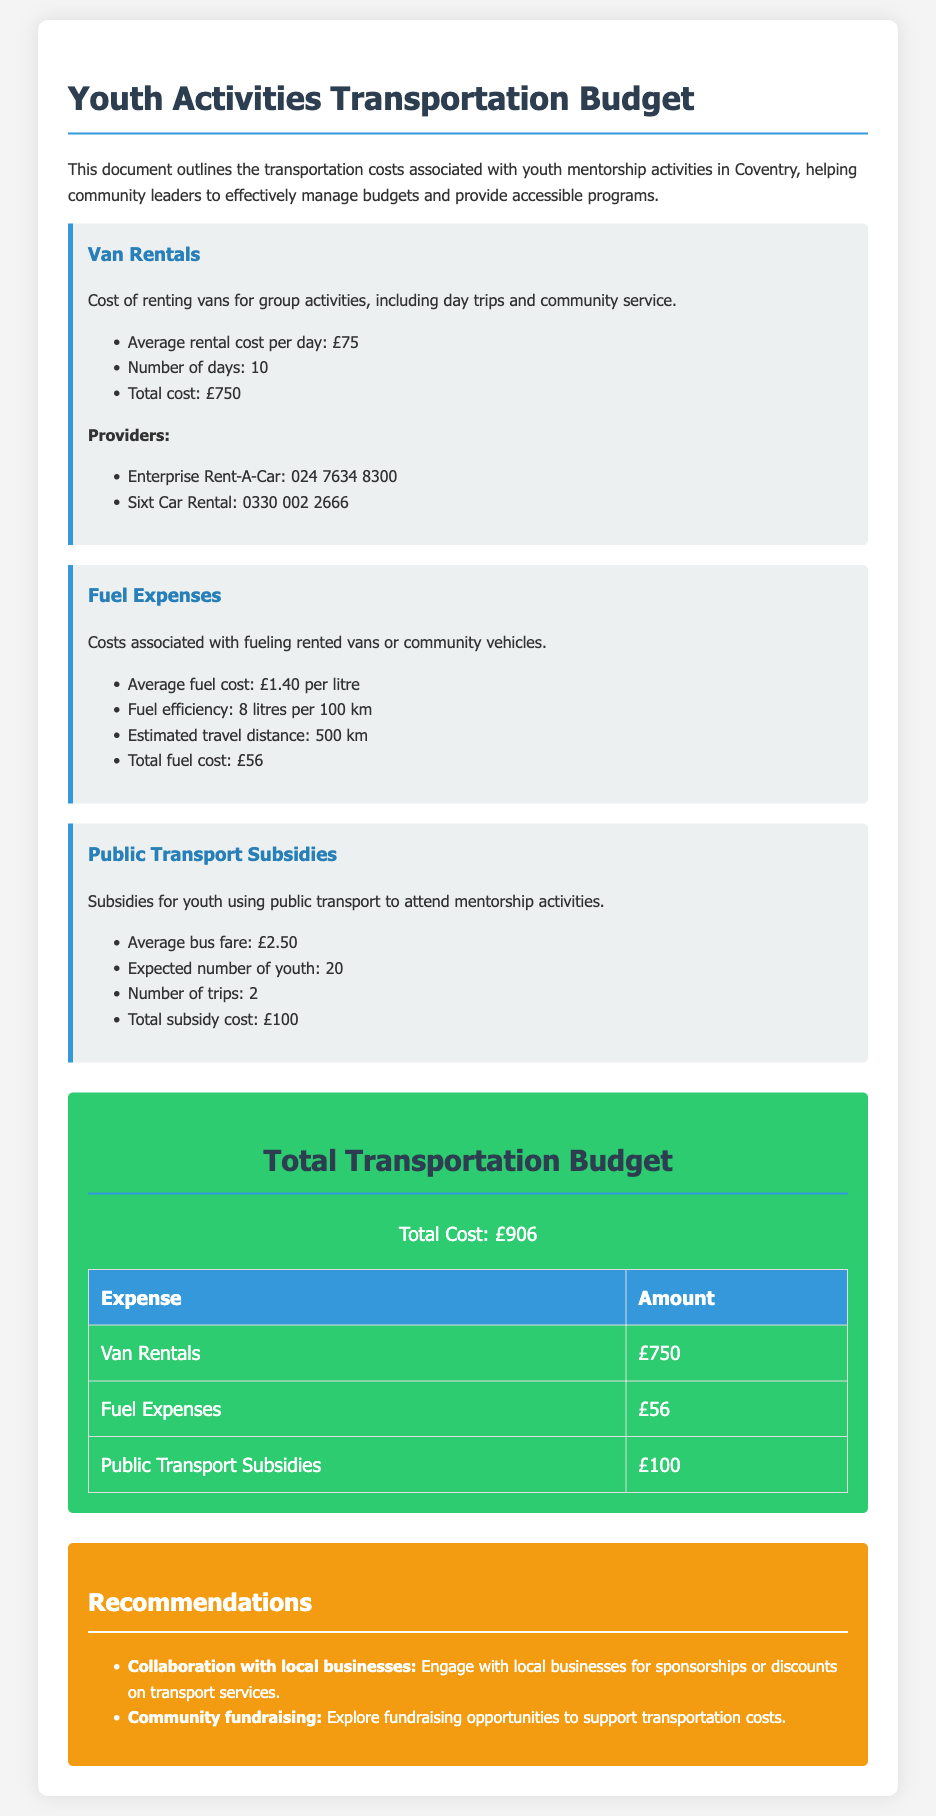what is the total cost of van rentals? The total cost of van rentals is provided in the expense section for Van Rentals.
Answer: £750 what is the average fuel cost per litre? The average fuel cost per litre is mentioned in the Fuel Expenses section.
Answer: £1.40 how many trips are expected for public transport subsidies? The document states the number of trips expected for public transport subsidies in the Public Transport Subsidies section.
Answer: 2 what is the total transportation budget? The total transportation budget is summarized in the Total Budget section.
Answer: £906 what is the average bus fare? The average bus fare can be found under the Public Transport Subsidies section.
Answer: £2.50 how many youth are expected to use public transport? The expected number of youth using public transport is detailed in the Public Transport Subsidies section.
Answer: 20 what is the fuel efficiency of the vehicles? The fuel efficiency is noted in the Fuel Expenses section as a specific measure.
Answer: 8 litres per 100 km who are the providers of van rentals? The document provides names of van rental providers in the Van Rentals section.
Answer: Enterprise Rent-A-Car, Sixt Car Rental what recommendations are made related to transportation costs? Recommendations can be found in the Recommendations section, regarding transportation expenses.
Answer: Collaboration with local businesses, Community fundraising 